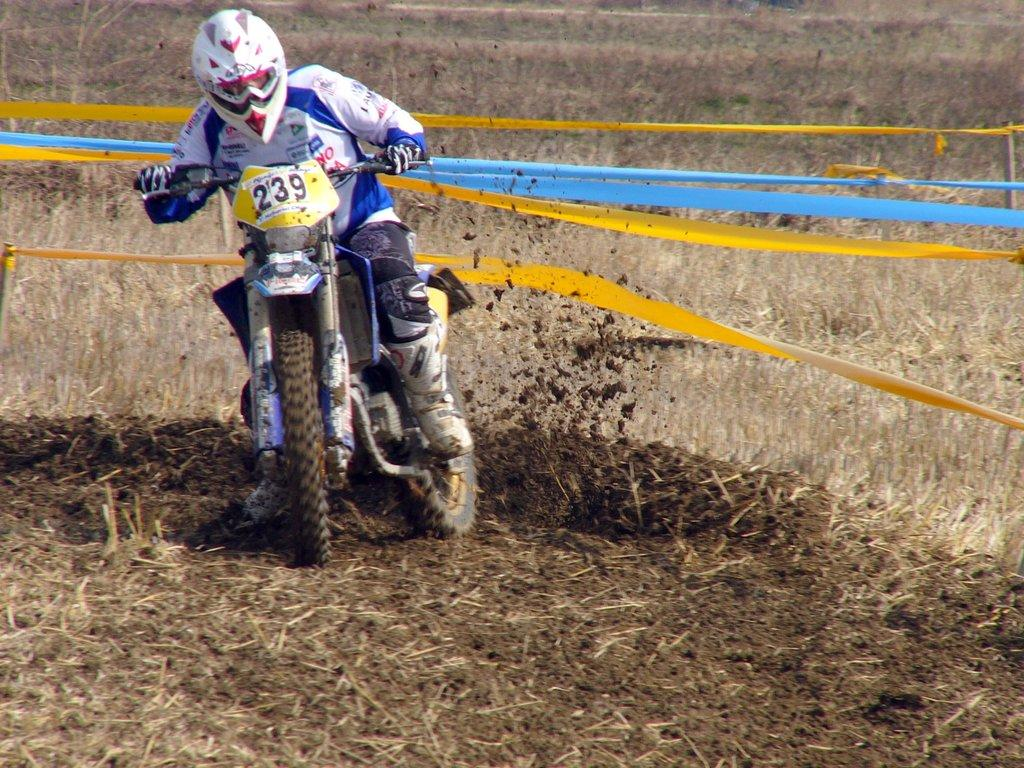What is the person in the image doing? The person in the image is with a motorbike. What can be seen hanging on the wooden poles in the image? Clothes are tied to wooden poles in the image. What type of vegetation is visible in the background of the image? There is dried grass in the background of the image. What type of board is the giraffe riding in the image? There is no giraffe or board present in the image. How is the chain attached to the motorbike in the image? There is no chain visible in the image; the person is with a motorbike, but no chain is mentioned in the facts. 